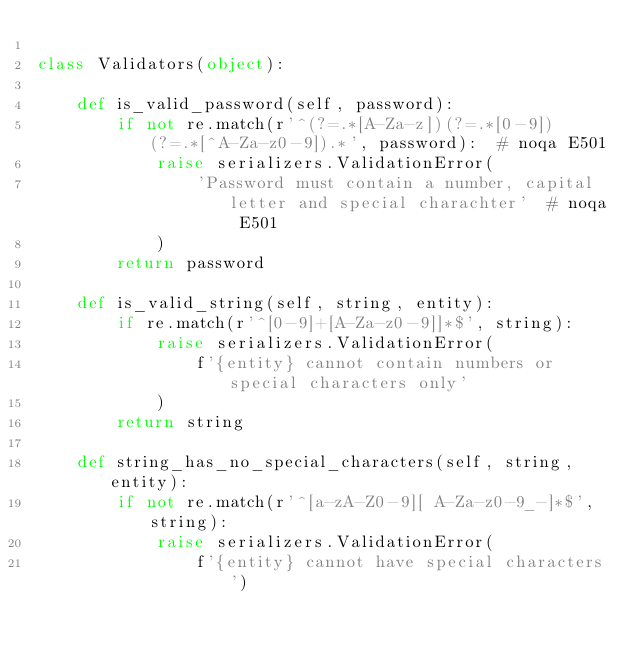<code> <loc_0><loc_0><loc_500><loc_500><_Python_>
class Validators(object):

    def is_valid_password(self, password):
        if not re.match(r'^(?=.*[A-Za-z])(?=.*[0-9])(?=.*[^A-Za-z0-9]).*', password):  # noqa E501
            raise serializers.ValidationError(
                'Password must contain a number, capital letter and special charachter'  # noqa E501
            )
        return password

    def is_valid_string(self, string, entity):
        if re.match(r'^[0-9]+[A-Za-z0-9]]*$', string):
            raise serializers.ValidationError(
                f'{entity} cannot contain numbers or special characters only'
            )
        return string

    def string_has_no_special_characters(self, string, entity):
        if not re.match(r'^[a-zA-Z0-9][ A-Za-z0-9_-]*$', string):
            raise serializers.ValidationError(
                f'{entity} cannot have special characters')
</code> 